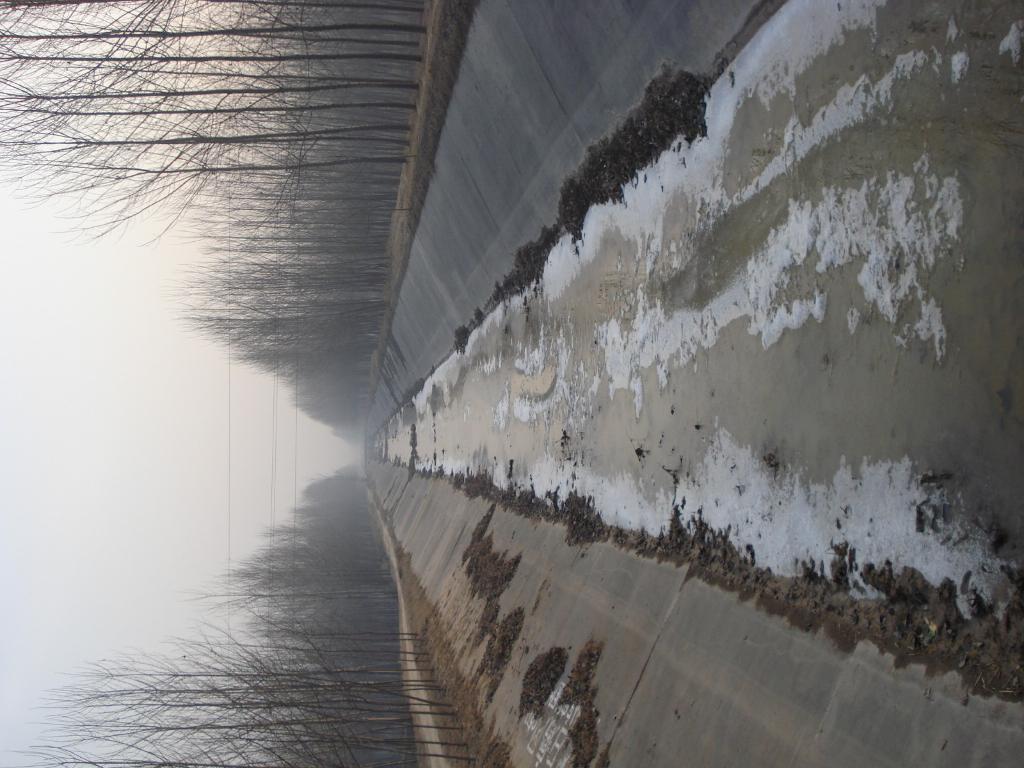Describe this image in one or two sentences. In this image we can see group of trees ,a water canal and in the background we can see the sky. 